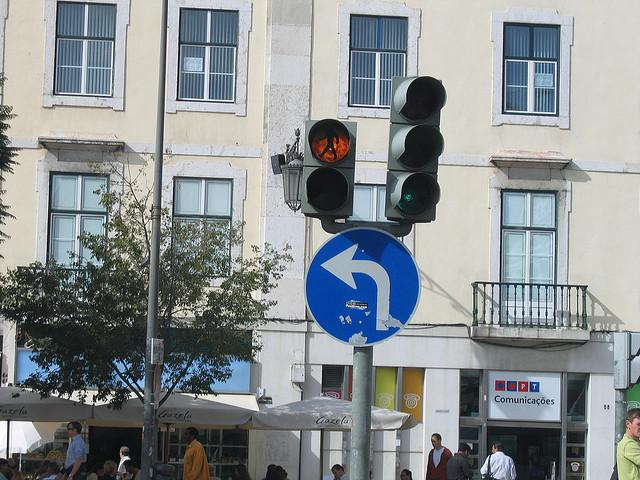What is the sign telling drivers?

Choices:
A) left only
B) go straight
C) no u-turns
D) right only left only 